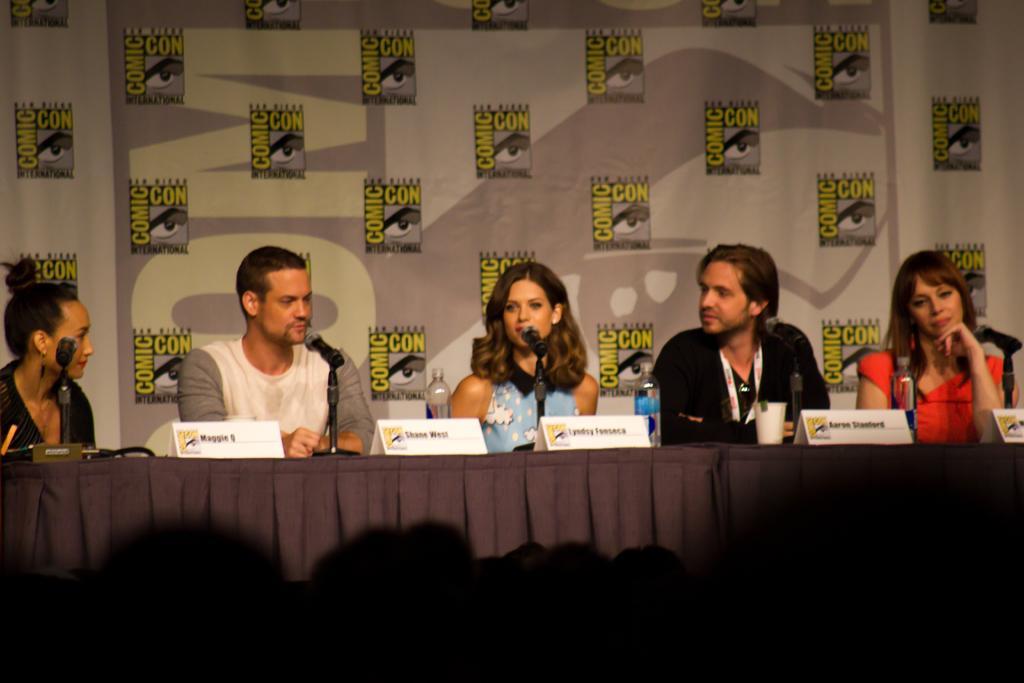Please provide a concise description of this image. This picture shows a group of people seated on the chairs and speaking with the help of a microphones and we see a hoarding back of them. 